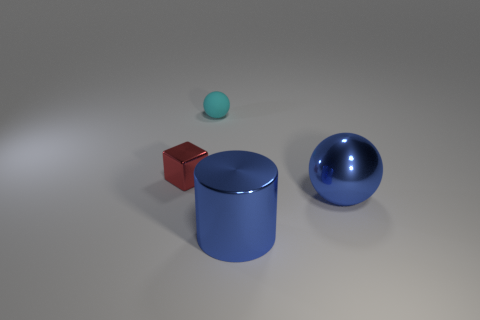What shape is the big object that is the same color as the large cylinder?
Keep it short and to the point. Sphere. The metallic object that is the same shape as the tiny matte object is what size?
Offer a very short reply. Large. Are there any other things that have the same material as the cyan thing?
Keep it short and to the point. No. Is the tiny ball made of the same material as the ball that is to the right of the matte sphere?
Your response must be concise. No. What is the material of the object that is to the right of the thing in front of the sphere in front of the small shiny block?
Offer a very short reply. Metal. Is the object in front of the large blue metallic sphere made of the same material as the tiny object on the right side of the red object?
Offer a very short reply. No. How many other things are there of the same color as the metal block?
Offer a terse response. 0. The matte sphere has what size?
Give a very brief answer. Small. Are there any big cyan blocks?
Provide a short and direct response. No. Are there more large cylinders that are behind the red metal thing than cyan things on the right side of the tiny matte object?
Offer a very short reply. No. 